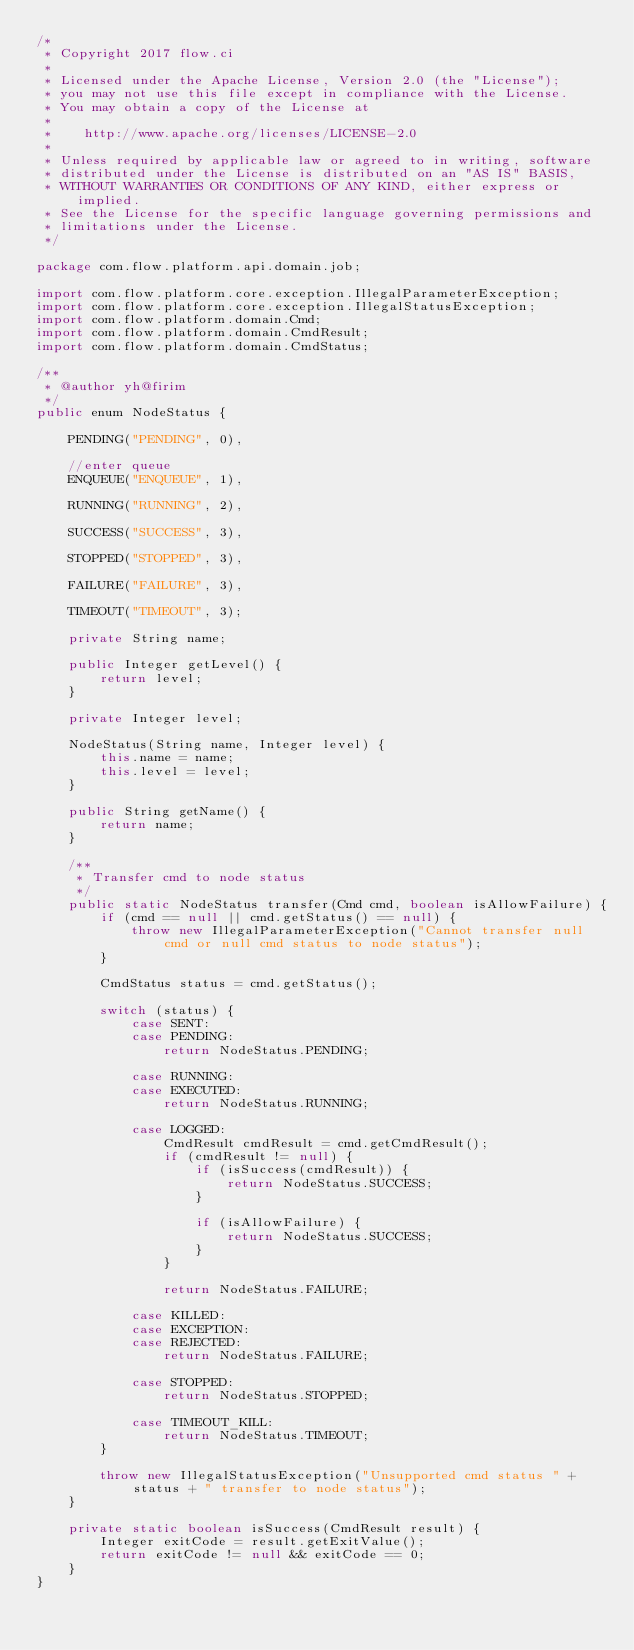<code> <loc_0><loc_0><loc_500><loc_500><_Java_>/*
 * Copyright 2017 flow.ci
 *
 * Licensed under the Apache License, Version 2.0 (the "License");
 * you may not use this file except in compliance with the License.
 * You may obtain a copy of the License at
 *
 *    http://www.apache.org/licenses/LICENSE-2.0
 *
 * Unless required by applicable law or agreed to in writing, software
 * distributed under the License is distributed on an "AS IS" BASIS,
 * WITHOUT WARRANTIES OR CONDITIONS OF ANY KIND, either express or implied.
 * See the License for the specific language governing permissions and
 * limitations under the License.
 */

package com.flow.platform.api.domain.job;

import com.flow.platform.core.exception.IllegalParameterException;
import com.flow.platform.core.exception.IllegalStatusException;
import com.flow.platform.domain.Cmd;
import com.flow.platform.domain.CmdResult;
import com.flow.platform.domain.CmdStatus;

/**
 * @author yh@firim
 */
public enum NodeStatus {

    PENDING("PENDING", 0),

    //enter queue
    ENQUEUE("ENQUEUE", 1),

    RUNNING("RUNNING", 2),

    SUCCESS("SUCCESS", 3),

    STOPPED("STOPPED", 3),

    FAILURE("FAILURE", 3),

    TIMEOUT("TIMEOUT", 3);

    private String name;

    public Integer getLevel() {
        return level;
    }

    private Integer level;

    NodeStatus(String name, Integer level) {
        this.name = name;
        this.level = level;
    }

    public String getName() {
        return name;
    }

    /**
     * Transfer cmd to node status
     */
    public static NodeStatus transfer(Cmd cmd, boolean isAllowFailure) {
        if (cmd == null || cmd.getStatus() == null) {
            throw new IllegalParameterException("Cannot transfer null cmd or null cmd status to node status");
        }

        CmdStatus status = cmd.getStatus();

        switch (status) {
            case SENT:
            case PENDING:
                return NodeStatus.PENDING;

            case RUNNING:
            case EXECUTED:
                return NodeStatus.RUNNING;

            case LOGGED:
                CmdResult cmdResult = cmd.getCmdResult();
                if (cmdResult != null) {
                    if (isSuccess(cmdResult)) {
                        return NodeStatus.SUCCESS;
                    }

                    if (isAllowFailure) {
                        return NodeStatus.SUCCESS;
                    }
                }

                return NodeStatus.FAILURE;

            case KILLED:
            case EXCEPTION:
            case REJECTED:
                return NodeStatus.FAILURE;

            case STOPPED:
                return NodeStatus.STOPPED;

            case TIMEOUT_KILL:
                return NodeStatus.TIMEOUT;
        }

        throw new IllegalStatusException("Unsupported cmd status " + status + " transfer to node status");
    }

    private static boolean isSuccess(CmdResult result) {
        Integer exitCode = result.getExitValue();
        return exitCode != null && exitCode == 0;
    }
}
</code> 